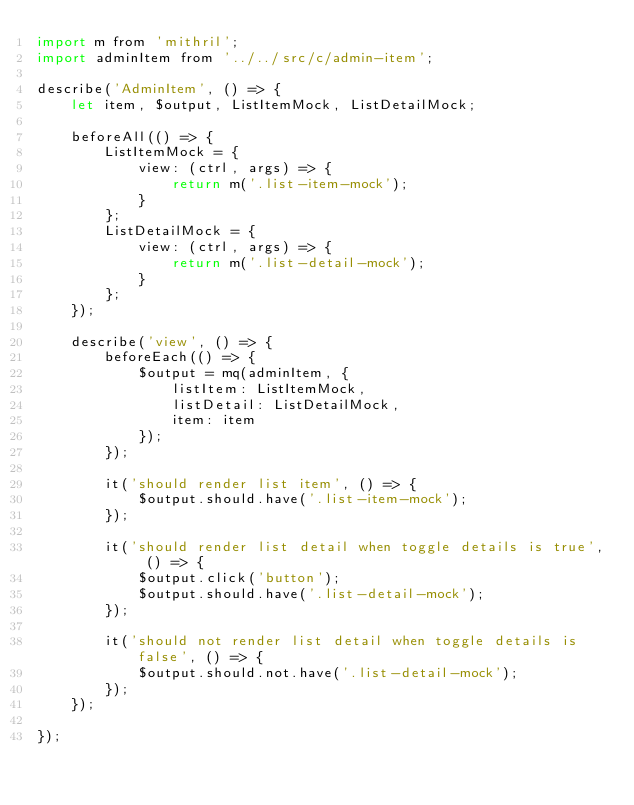<code> <loc_0><loc_0><loc_500><loc_500><_JavaScript_>import m from 'mithril';
import adminItem from '../../src/c/admin-item';

describe('AdminItem', () => {
    let item, $output, ListItemMock, ListDetailMock;

    beforeAll(() => {
        ListItemMock = {
            view: (ctrl, args) => {
                return m('.list-item-mock');
            }
        };
        ListDetailMock = {
            view: (ctrl, args) => {
                return m('.list-detail-mock');
            }
        };
    });

    describe('view', () => {
        beforeEach(() => {
            $output = mq(adminItem, {
                listItem: ListItemMock,
                listDetail: ListDetailMock,
                item: item
            });
        });

        it('should render list item', () => {
            $output.should.have('.list-item-mock');
        });

        it('should render list detail when toggle details is true', () => {
            $output.click('button');
            $output.should.have('.list-detail-mock');
        });

        it('should not render list detail when toggle details is false', () => {
            $output.should.not.have('.list-detail-mock');
        });
    });

});
</code> 